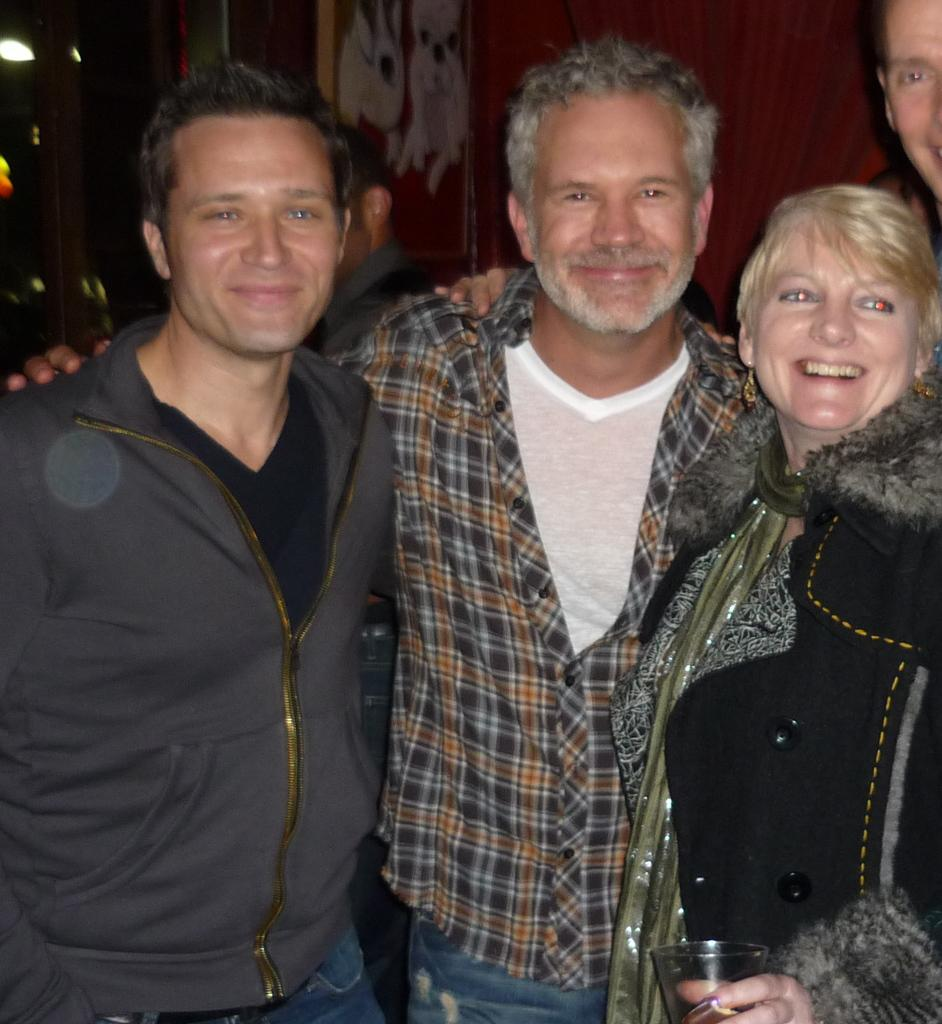How many people are present in the image? There are five people in the image. What is the facial expression of some of the people in the image? Three of the people are smiling. What position are three of the people in the image? Three of the people are standing. What can be seen in the background of the image? There is a wall and lights in the background of the image. How would you describe the lighting conditions in the image? The background is dark. What is the name of the bear that is present in the image? There is no bear present in the image. What type of pet can be seen in the image? There is no pet visible in the image. 